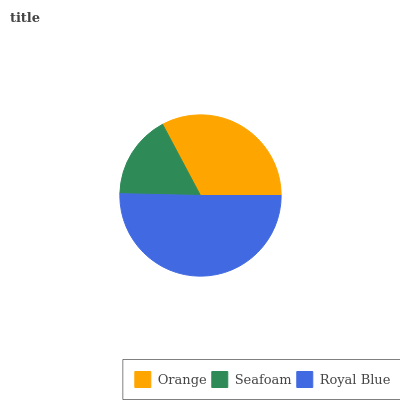Is Seafoam the minimum?
Answer yes or no. Yes. Is Royal Blue the maximum?
Answer yes or no. Yes. Is Royal Blue the minimum?
Answer yes or no. No. Is Seafoam the maximum?
Answer yes or no. No. Is Royal Blue greater than Seafoam?
Answer yes or no. Yes. Is Seafoam less than Royal Blue?
Answer yes or no. Yes. Is Seafoam greater than Royal Blue?
Answer yes or no. No. Is Royal Blue less than Seafoam?
Answer yes or no. No. Is Orange the high median?
Answer yes or no. Yes. Is Orange the low median?
Answer yes or no. Yes. Is Royal Blue the high median?
Answer yes or no. No. Is Royal Blue the low median?
Answer yes or no. No. 